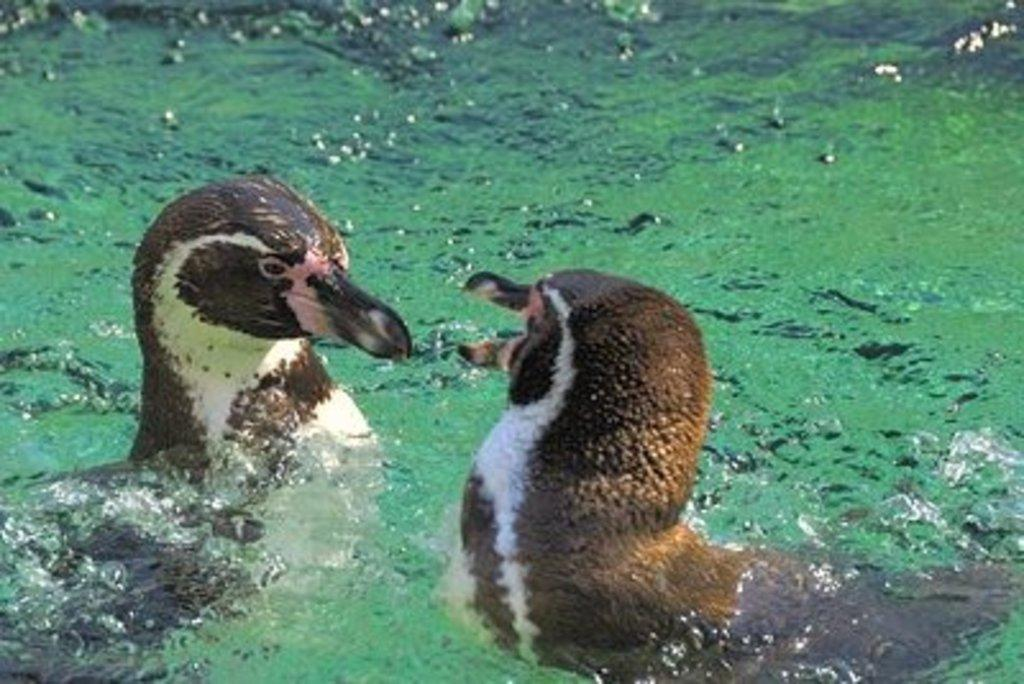What animals are present in the image? There are two ducks in the image. Where are the ducks located? The ducks are in the water. What type of fuel is being used by the ducks in the image? There is no fuel present in the image, as it features two ducks in the water. 